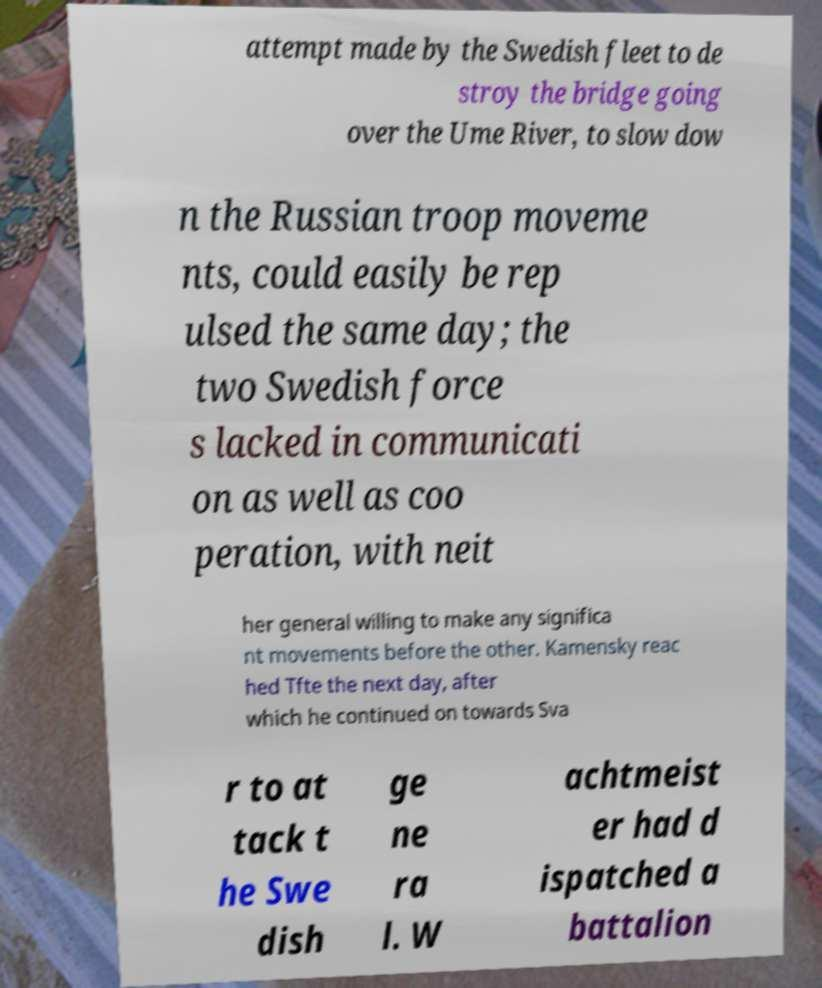Could you extract and type out the text from this image? attempt made by the Swedish fleet to de stroy the bridge going over the Ume River, to slow dow n the Russian troop moveme nts, could easily be rep ulsed the same day; the two Swedish force s lacked in communicati on as well as coo peration, with neit her general willing to make any significa nt movements before the other. Kamensky reac hed Tfte the next day, after which he continued on towards Sva r to at tack t he Swe dish ge ne ra l. W achtmeist er had d ispatched a battalion 